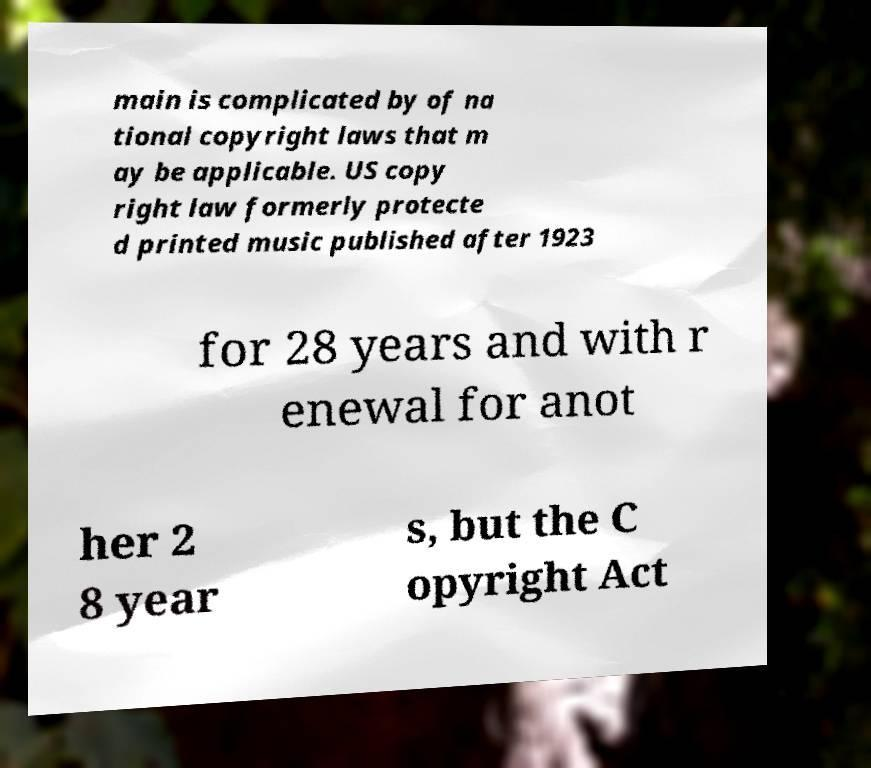I need the written content from this picture converted into text. Can you do that? main is complicated by of na tional copyright laws that m ay be applicable. US copy right law formerly protecte d printed music published after 1923 for 28 years and with r enewal for anot her 2 8 year s, but the C opyright Act 